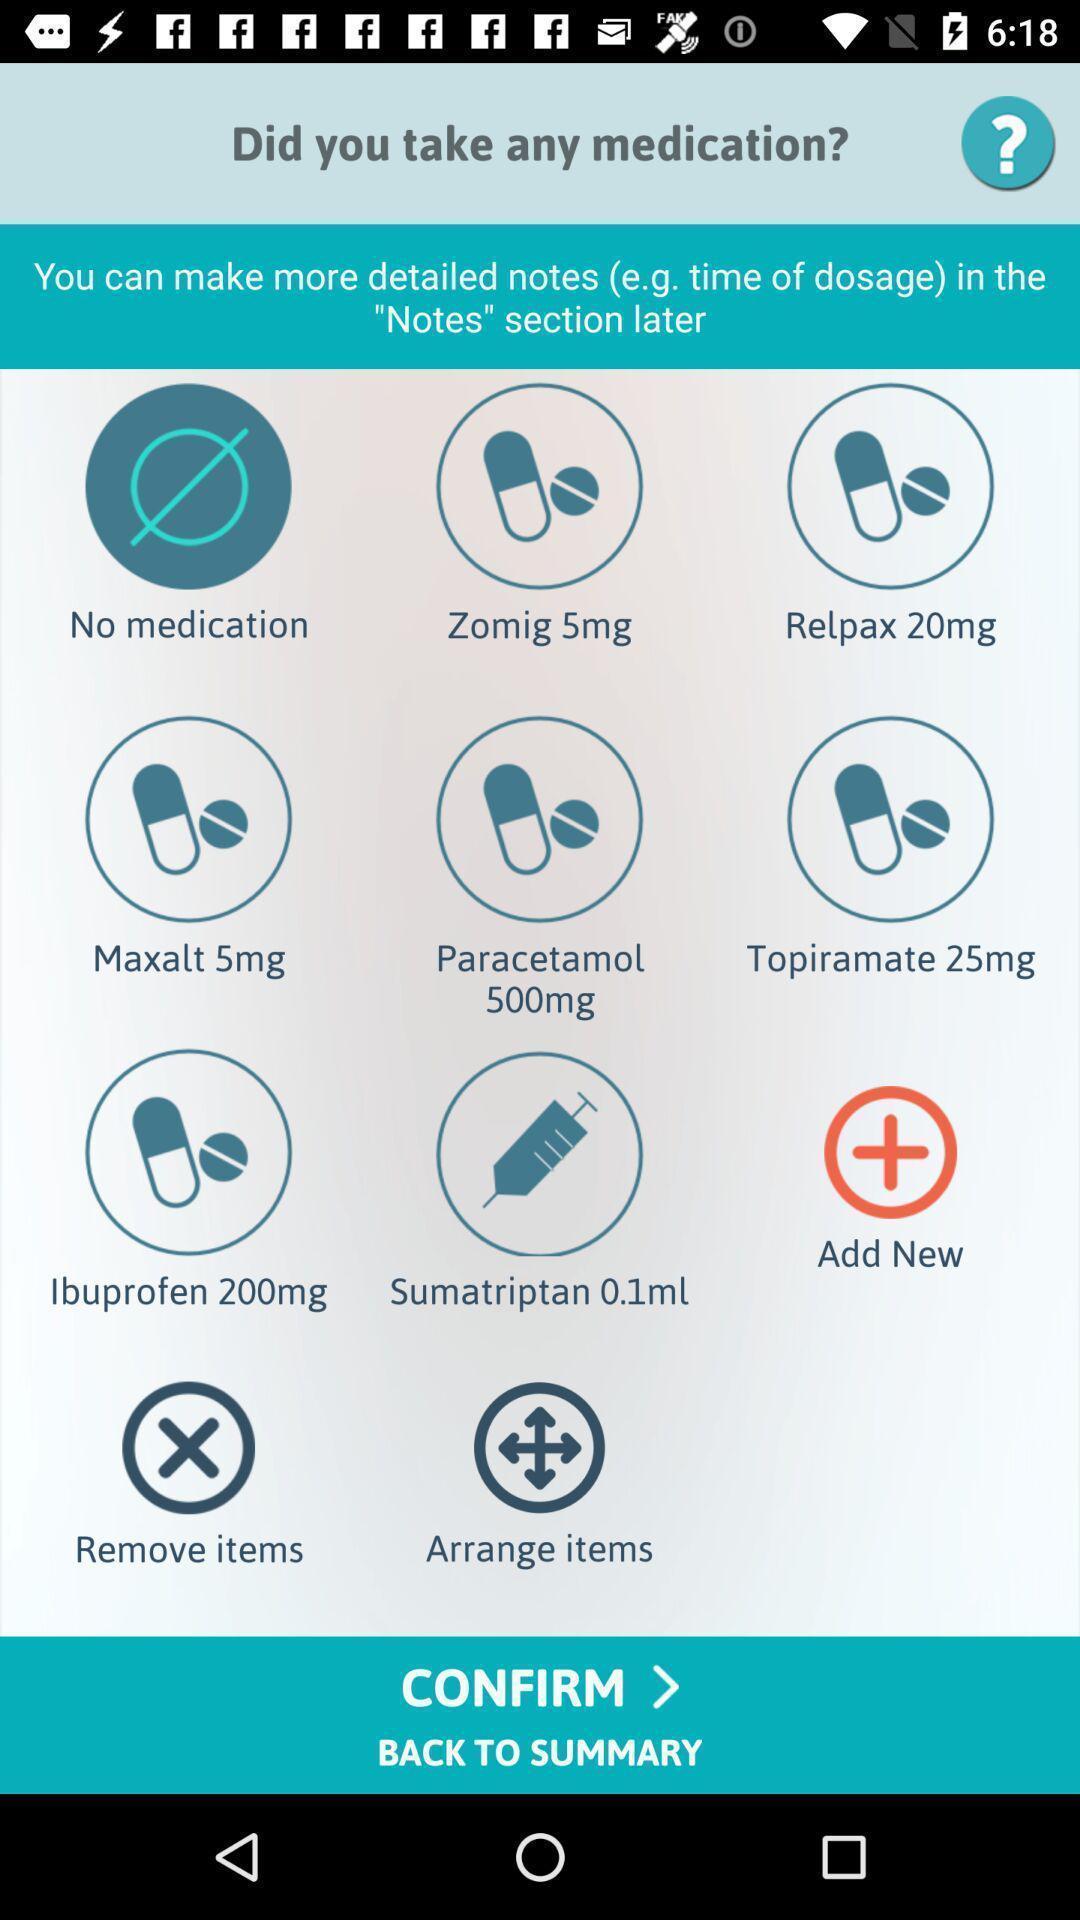Give me a narrative description of this picture. Screen displaying the page of a medical app. 